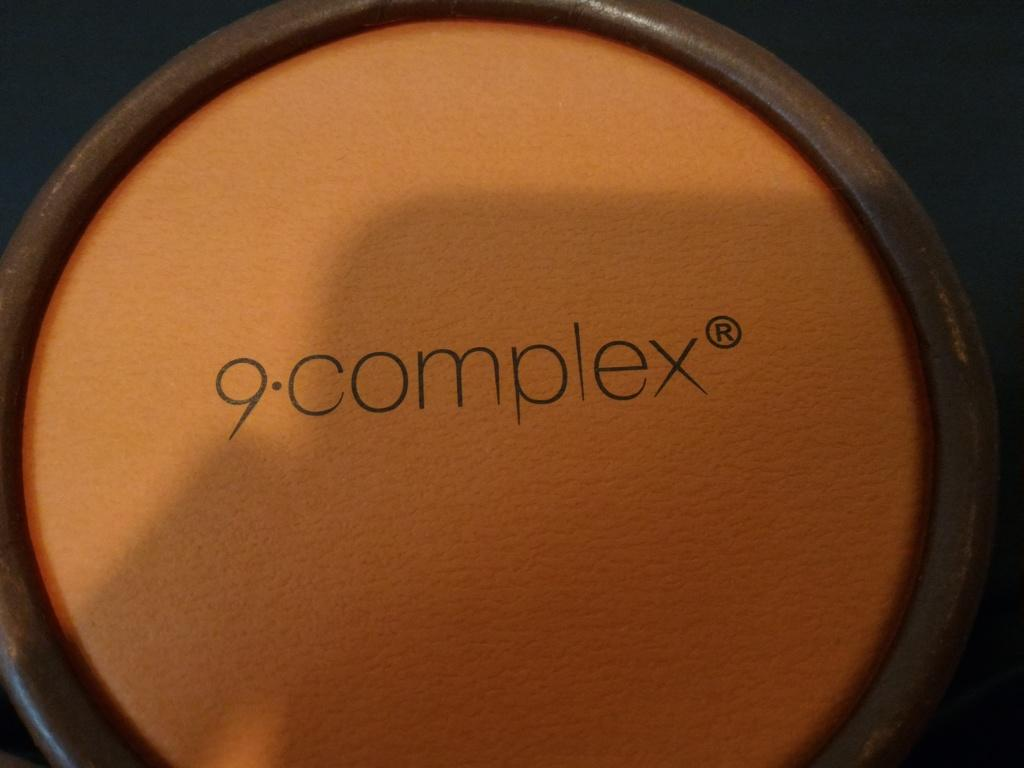<image>
Present a compact description of the photo's key features. A closeup of 9complex cosmetic cream that is orange and brown in color. 